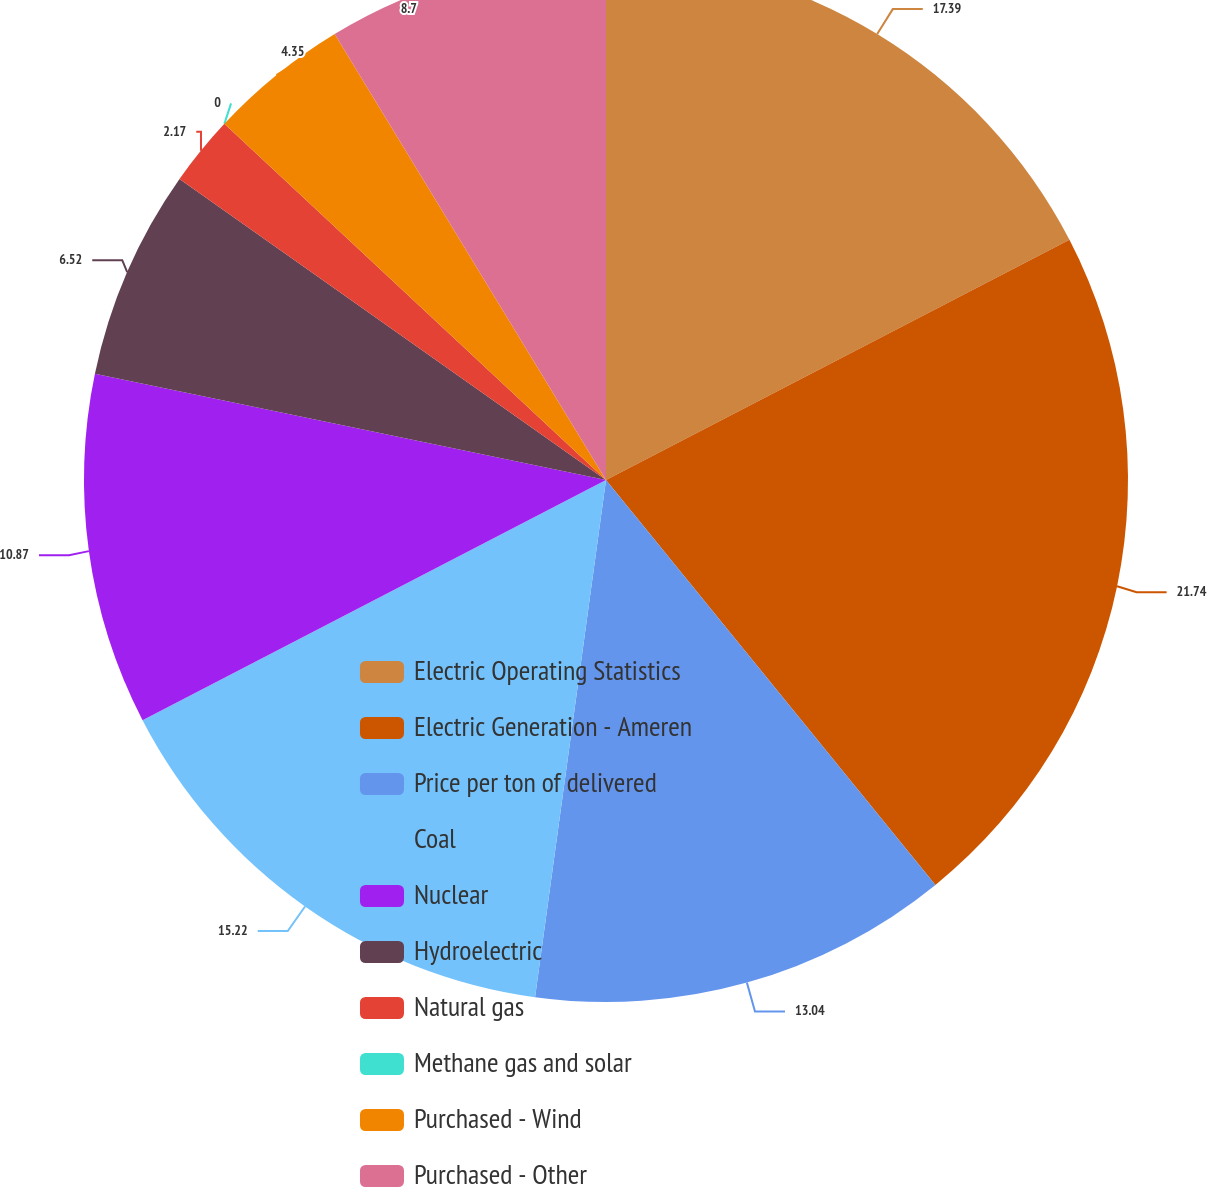<chart> <loc_0><loc_0><loc_500><loc_500><pie_chart><fcel>Electric Operating Statistics<fcel>Electric Generation - Ameren<fcel>Price per ton of delivered<fcel>Coal<fcel>Nuclear<fcel>Hydroelectric<fcel>Natural gas<fcel>Methane gas and solar<fcel>Purchased - Wind<fcel>Purchased - Other<nl><fcel>17.39%<fcel>21.74%<fcel>13.04%<fcel>15.22%<fcel>10.87%<fcel>6.52%<fcel>2.17%<fcel>0.0%<fcel>4.35%<fcel>8.7%<nl></chart> 